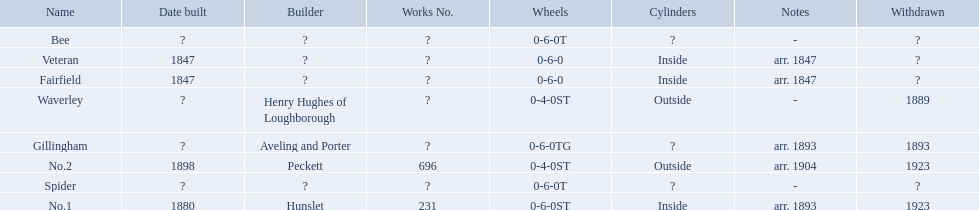What are the aldernay railways? Veteran, Fairfield, Waverley, Bee, Spider, Gillingham, No.1, No.2. Which ones were built in 1847? Veteran, Fairfield. Of those, which one is not fairfield? Veteran. 